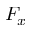Convert formula to latex. <formula><loc_0><loc_0><loc_500><loc_500>F _ { x }</formula> 